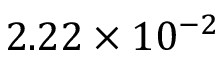<formula> <loc_0><loc_0><loc_500><loc_500>2 . 2 2 \times 1 0 ^ { - 2 }</formula> 